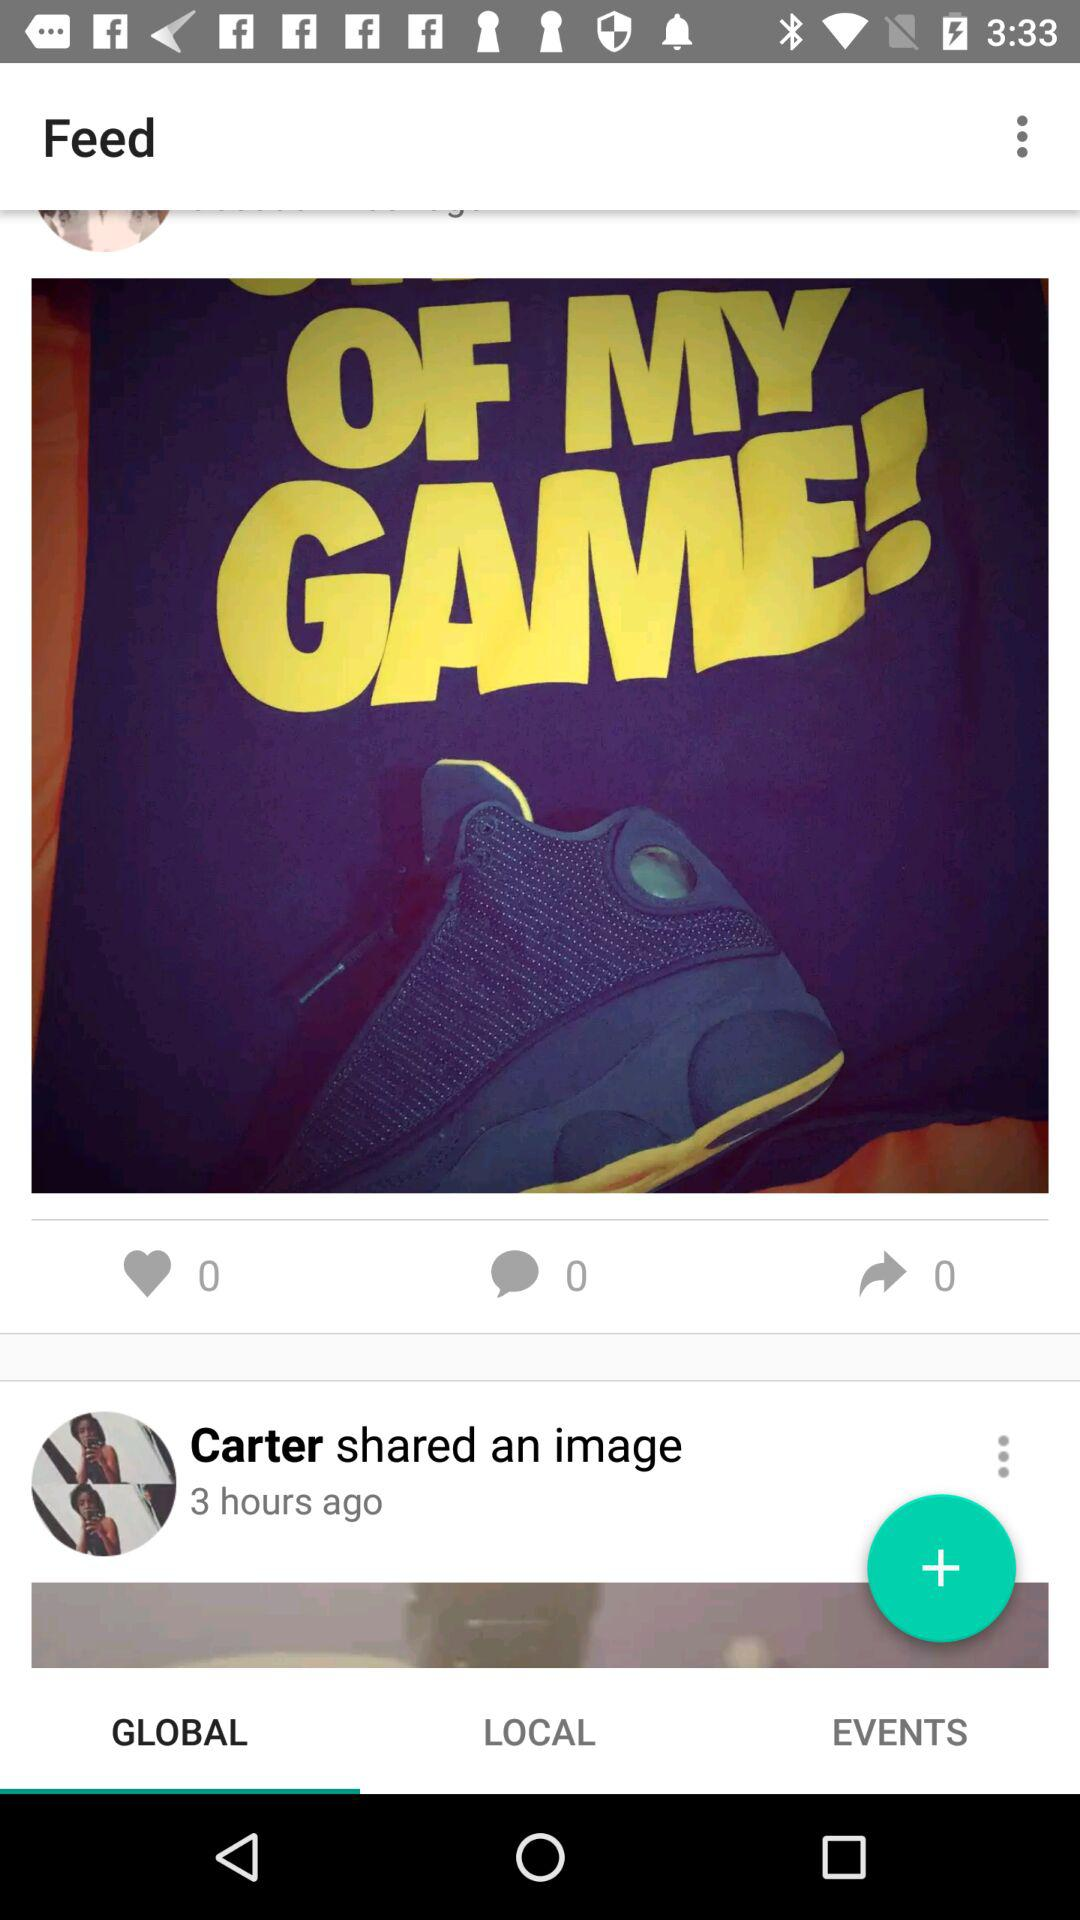Which tab is selected? The selected tab is "GLOBAL". 